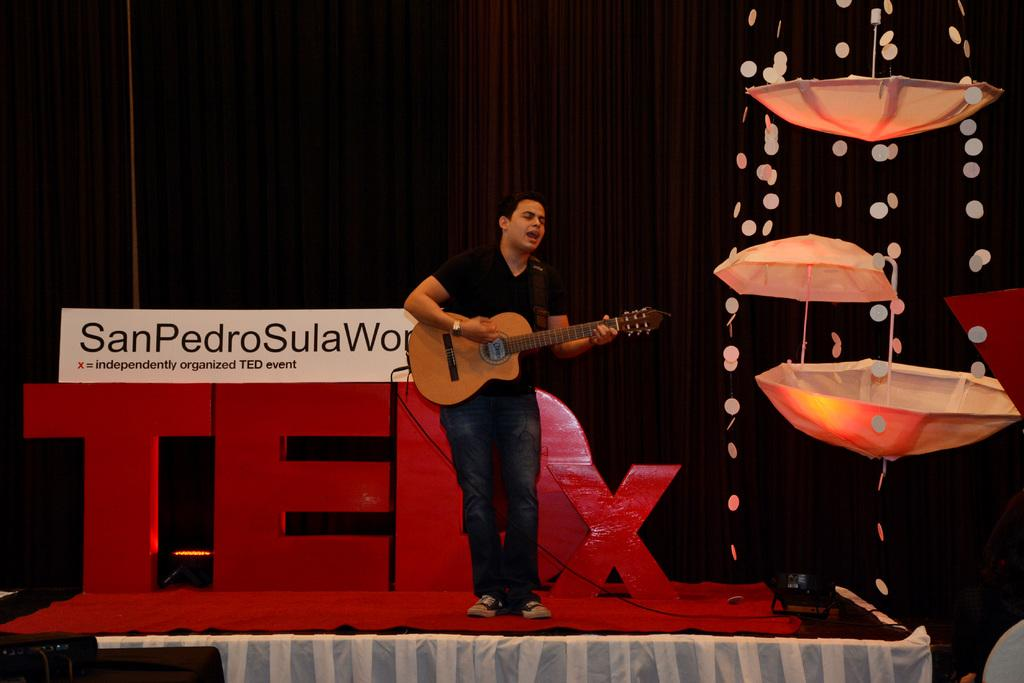What objects are present in the image that can provide protection from rain or sunlight? There are umbrellas in the image. What can be seen in the image that provides illumination? There are lights in the image. What type of flooring is visible in the image? There is a red color carpet in the image. What type of window treatment is present in the image? There are curtains in the image. What activity is the man in the image engaged in? The man in the image is holding a guitar. Can you tell me how many needles are visible in the image? There are no needles present in the image. What type of vein is visible on the man's hand in the image? There is no man's hand visible in the image, and even if there were, it would not be possible to see veins through the skin in a photograph. 